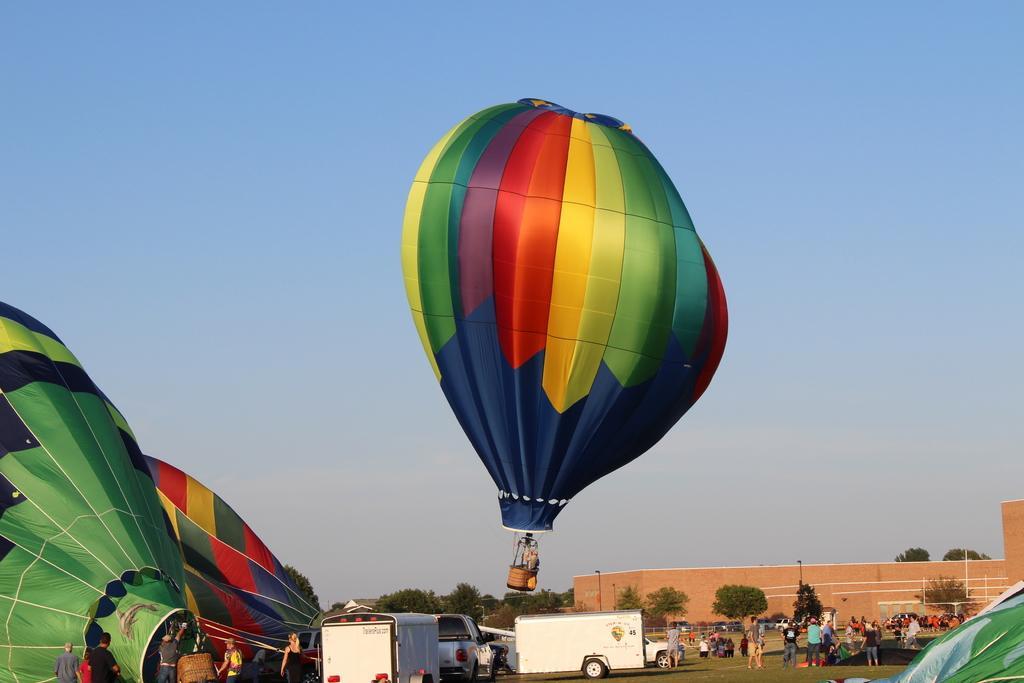Please provide a concise description of this image. In this picture I can see the hot air balloon in the center of the image. I can see a few people on the right side. I can see a few people on the left side near to hot air balloon. I can see the vehicles on the green grass. I can see clouds in the sky. 